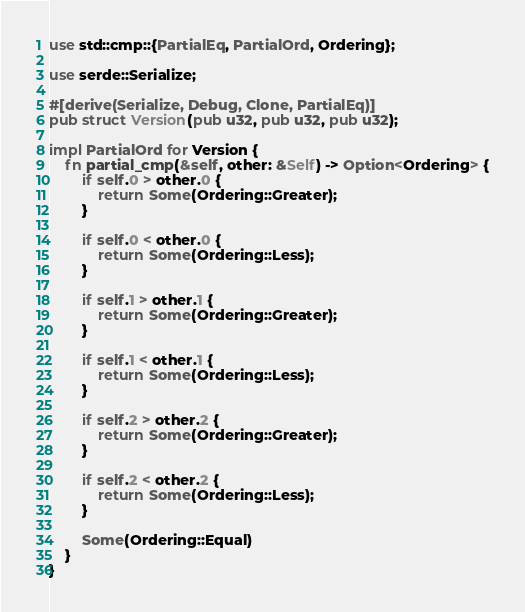<code> <loc_0><loc_0><loc_500><loc_500><_Rust_>use std::cmp::{PartialEq, PartialOrd, Ordering};

use serde::Serialize;

#[derive(Serialize, Debug, Clone, PartialEq)]
pub struct Version(pub u32, pub u32, pub u32);

impl PartialOrd for Version {
    fn partial_cmp(&self, other: &Self) -> Option<Ordering> {
        if self.0 > other.0 {
            return Some(Ordering::Greater);
        }

        if self.0 < other.0 {
            return Some(Ordering::Less);
        }

        if self.1 > other.1 {
            return Some(Ordering::Greater);
        }

        if self.1 < other.1 {
            return Some(Ordering::Less);
        }

        if self.2 > other.2 {
            return Some(Ordering::Greater);
        }

        if self.2 < other.2 {
            return Some(Ordering::Less);
        }

        Some(Ordering::Equal)
    }
}
</code> 